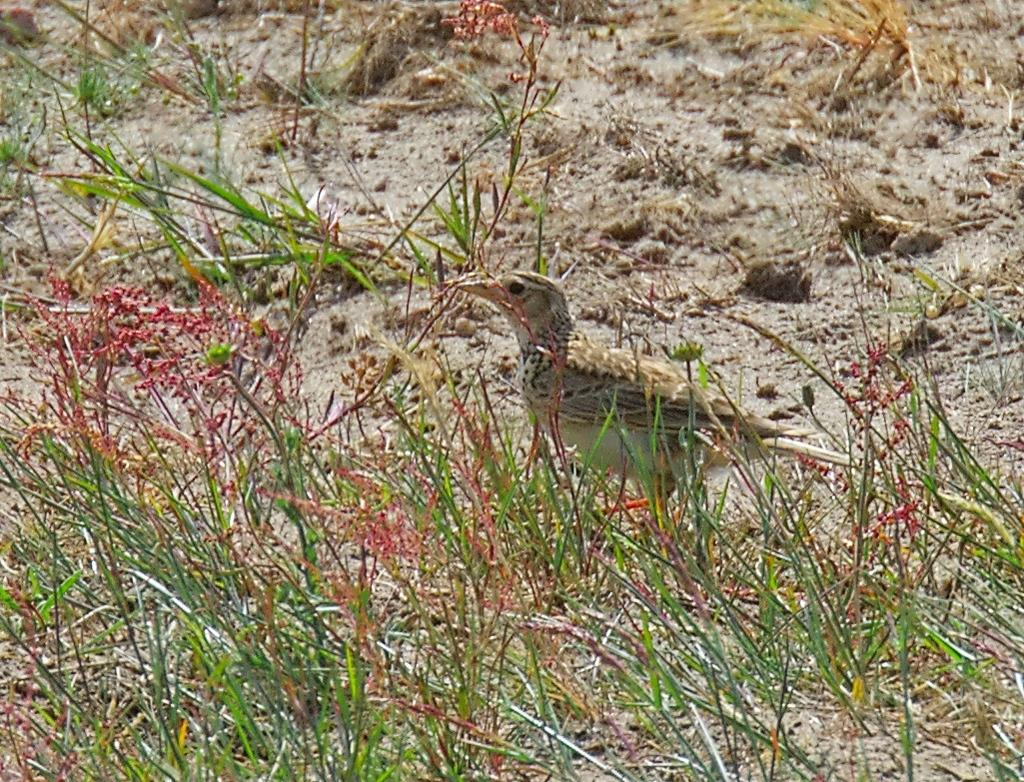What type of animal can be seen in the image? There is a bird in the image. Where is the bird located in the image? The bird is standing on the ground. What type of vegetation is visible in the image? Grass is visible in the image. What type of umbrella is the bird holding in the image? There is no umbrella present in the image; the bird is standing on the ground. Can you tell me how many frogs are visible in the image? There are no frogs present in the image; only a bird is visible. 